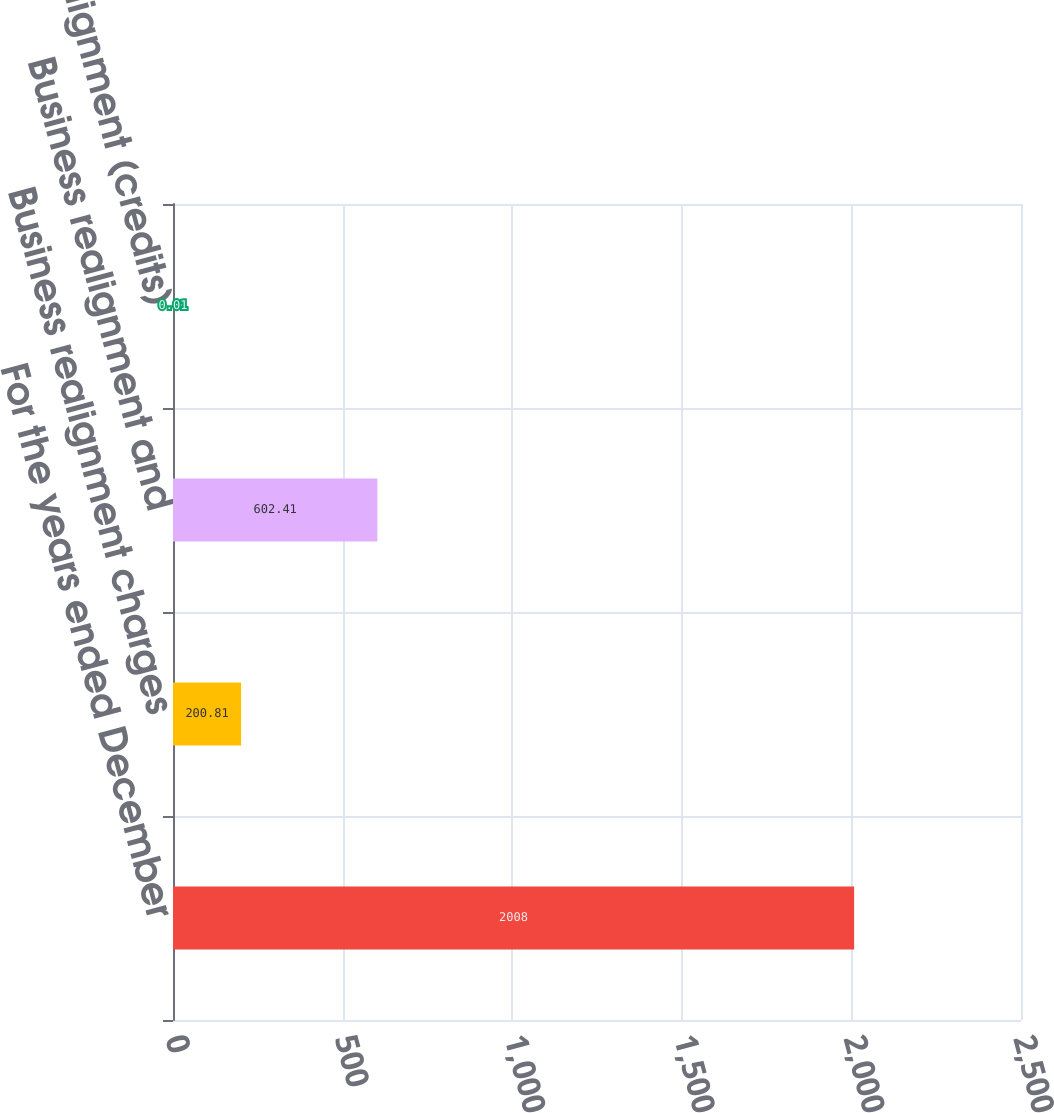Convert chart to OTSL. <chart><loc_0><loc_0><loc_500><loc_500><bar_chart><fcel>For the years ended December<fcel>Business realignment charges<fcel>Business realignment and<fcel>Business realignment (credits)<nl><fcel>2008<fcel>200.81<fcel>602.41<fcel>0.01<nl></chart> 